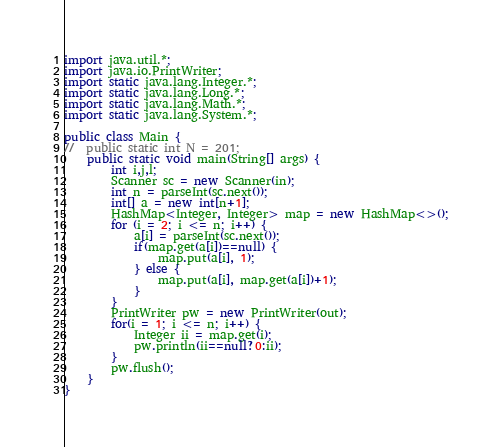<code> <loc_0><loc_0><loc_500><loc_500><_Java_>import java.util.*;
import java.io.PrintWriter;
import static java.lang.Integer.*;
import static java.lang.Long.*;
import static java.lang.Math.*;
import static java.lang.System.*;

public class Main {
//	public static int N = 201;
	public static void main(String[] args) {
		int i,j,l;
		Scanner sc = new Scanner(in);
		int n = parseInt(sc.next());
		int[] a = new int[n+1];
		HashMap<Integer, Integer> map = new HashMap<>();
		for (i = 2; i <= n; i++) {
			a[i] = parseInt(sc.next());
			if(map.get(a[i])==null) {
				map.put(a[i], 1);
			} else {
				map.put(a[i], map.get(a[i])+1);
			}
		}
		PrintWriter pw = new PrintWriter(out);
		for(i = 1; i <= n; i++) {
			Integer ii = map.get(i);
			pw.println(ii==null?0:ii);
		}
		pw.flush();
	}
}
</code> 